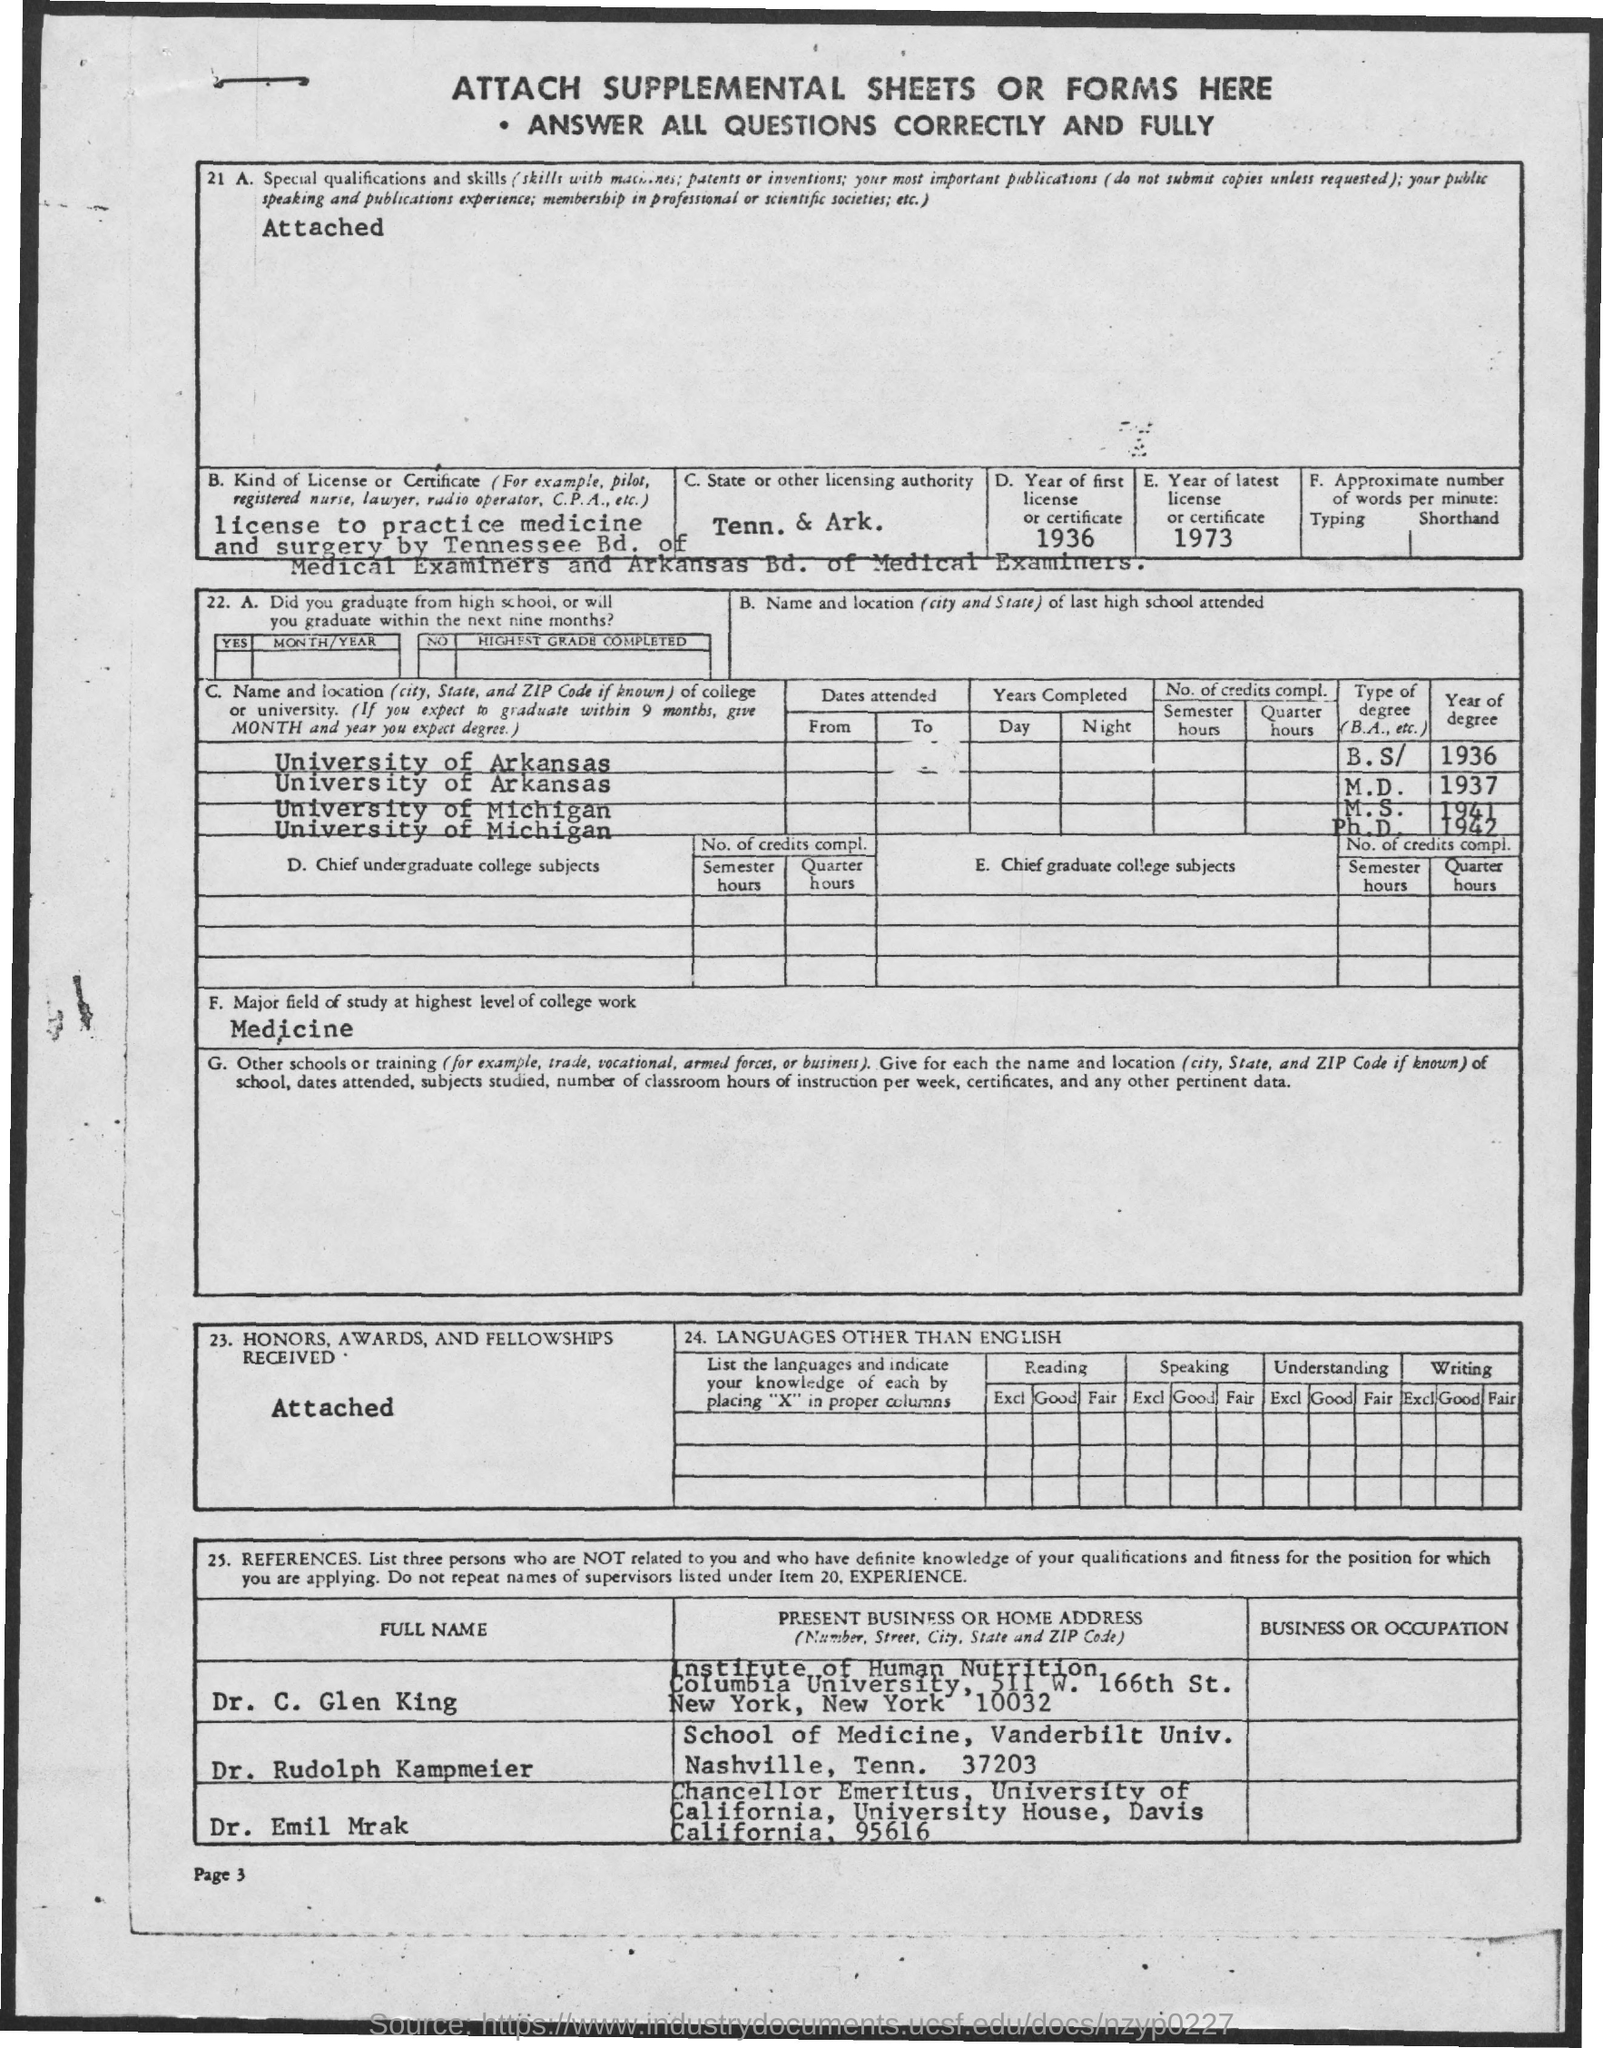Highlight a few significant elements in this photo. The year of the first license or certificate was 1936. The state of Tennessee and the state of Arkansas are the respective licensing authorities for C. The major field of study at the highest level of college work is medicine. 